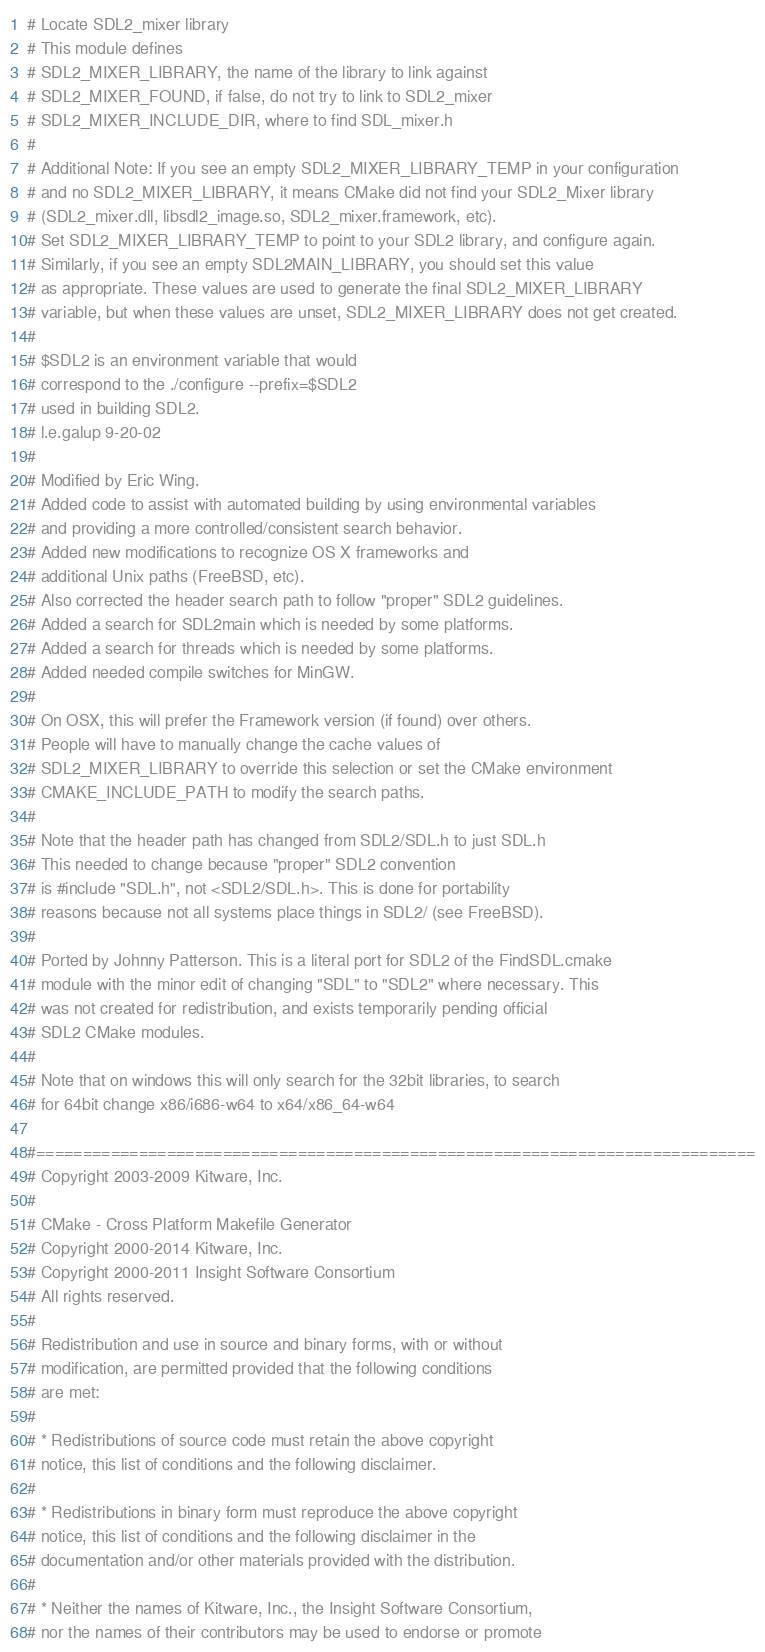<code> <loc_0><loc_0><loc_500><loc_500><_CMake_># Locate SDL2_mixer library
# This module defines
# SDL2_MIXER_LIBRARY, the name of the library to link against
# SDL2_MIXER_FOUND, if false, do not try to link to SDL2_mixer
# SDL2_MIXER_INCLUDE_DIR, where to find SDL_mixer.h
#
# Additional Note: If you see an empty SDL2_MIXER_LIBRARY_TEMP in your configuration
# and no SDL2_MIXER_LIBRARY, it means CMake did not find your SDL2_Mixer library
# (SDL2_mixer.dll, libsdl2_image.so, SDL2_mixer.framework, etc).
# Set SDL2_MIXER_LIBRARY_TEMP to point to your SDL2 library, and configure again.
# Similarly, if you see an empty SDL2MAIN_LIBRARY, you should set this value
# as appropriate. These values are used to generate the final SDL2_MIXER_LIBRARY
# variable, but when these values are unset, SDL2_MIXER_LIBRARY does not get created.
#
# $SDL2 is an environment variable that would
# correspond to the ./configure --prefix=$SDL2
# used in building SDL2.
# l.e.galup 9-20-02
#
# Modified by Eric Wing.
# Added code to assist with automated building by using environmental variables
# and providing a more controlled/consistent search behavior.
# Added new modifications to recognize OS X frameworks and
# additional Unix paths (FreeBSD, etc).
# Also corrected the header search path to follow "proper" SDL2 guidelines.
# Added a search for SDL2main which is needed by some platforms.
# Added a search for threads which is needed by some platforms.
# Added needed compile switches for MinGW.
#
# On OSX, this will prefer the Framework version (if found) over others.
# People will have to manually change the cache values of
# SDL2_MIXER_LIBRARY to override this selection or set the CMake environment
# CMAKE_INCLUDE_PATH to modify the search paths.
#
# Note that the header path has changed from SDL2/SDL.h to just SDL.h
# This needed to change because "proper" SDL2 convention
# is #include "SDL.h", not <SDL2/SDL.h>. This is done for portability
# reasons because not all systems place things in SDL2/ (see FreeBSD).
#
# Ported by Johnny Patterson. This is a literal port for SDL2 of the FindSDL.cmake
# module with the minor edit of changing "SDL" to "SDL2" where necessary. This
# was not created for redistribution, and exists temporarily pending official
# SDL2 CMake modules.
#
# Note that on windows this will only search for the 32bit libraries, to search
# for 64bit change x86/i686-w64 to x64/x86_64-w64

#=============================================================================
# Copyright 2003-2009 Kitware, Inc.
#
# CMake - Cross Platform Makefile Generator
# Copyright 2000-2014 Kitware, Inc.
# Copyright 2000-2011 Insight Software Consortium
# All rights reserved.
#
# Redistribution and use in source and binary forms, with or without
# modification, are permitted provided that the following conditions
# are met:
#
# * Redistributions of source code must retain the above copyright
# notice, this list of conditions and the following disclaimer.
#
# * Redistributions in binary form must reproduce the above copyright
# notice, this list of conditions and the following disclaimer in the
# documentation and/or other materials provided with the distribution.
#
# * Neither the names of Kitware, Inc., the Insight Software Consortium,
# nor the names of their contributors may be used to endorse or promote</code> 